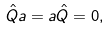<formula> <loc_0><loc_0><loc_500><loc_500>\hat { Q } a = a \hat { Q } = 0 ,</formula> 